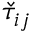<formula> <loc_0><loc_0><loc_500><loc_500>\check { \tau } _ { i j }</formula> 